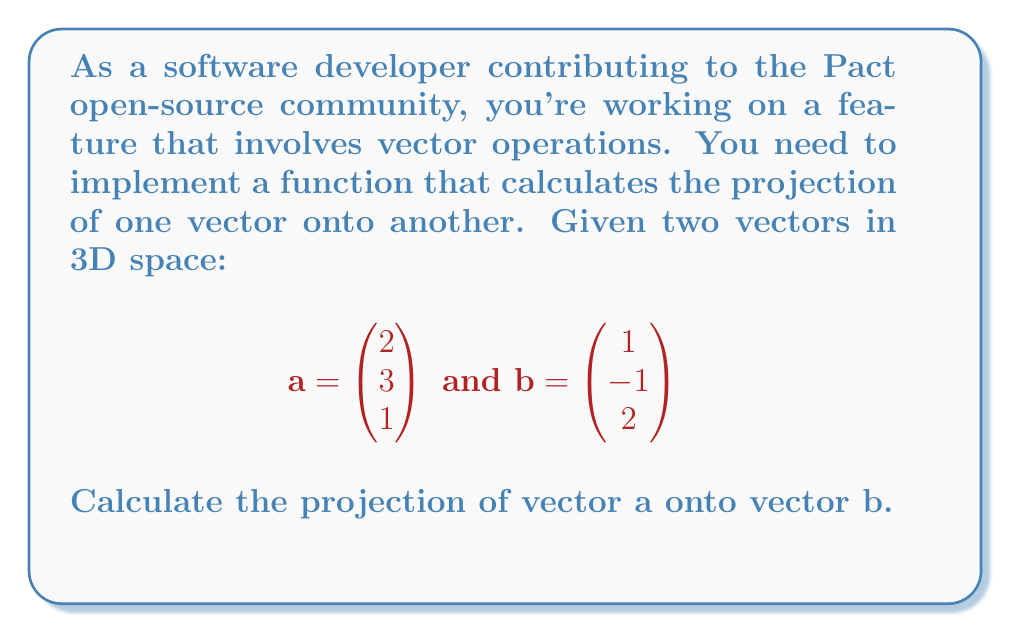Teach me how to tackle this problem. To find the projection of vector $\mathbf{a}$ onto vector $\mathbf{b}$, we use the formula:

$$\text{proj}_\mathbf{b} \mathbf{a} = \frac{\mathbf{a} \cdot \mathbf{b}}{\|\mathbf{b}\|^2} \mathbf{b}$$

Let's break this down step-by-step:

1) First, calculate the dot product $\mathbf{a} \cdot \mathbf{b}$:
   $$\mathbf{a} \cdot \mathbf{b} = (2)(1) + (3)(-1) + (1)(2) = 2 - 3 + 2 = 1$$

2) Next, calculate the magnitude of $\mathbf{b}$ squared, $\|\mathbf{b}\|^2$:
   $$\|\mathbf{b}\|^2 = 1^2 + (-1)^2 + 2^2 = 1 + 1 + 4 = 6$$

3) Now, calculate the scalar projection:
   $$\frac{\mathbf{a} \cdot \mathbf{b}}{\|\mathbf{b}\|^2} = \frac{1}{6}$$

4) Finally, multiply this scalar by vector $\mathbf{b}$ to get the vector projection:
   $$\text{proj}_\mathbf{b} \mathbf{a} = \frac{1}{6} \mathbf{b} = \frac{1}{6} \begin{pmatrix} 1 \\ -1 \\ 2 \end{pmatrix} = \begin{pmatrix} 1/6 \\ -1/6 \\ 1/3 \end{pmatrix}$$

This result gives us the vector projection of $\mathbf{a}$ onto $\mathbf{b}$.
Answer: $$\text{proj}_\mathbf{b} \mathbf{a} = \begin{pmatrix} 1/6 \\ -1/6 \\ 1/3 \end{pmatrix}$$ 